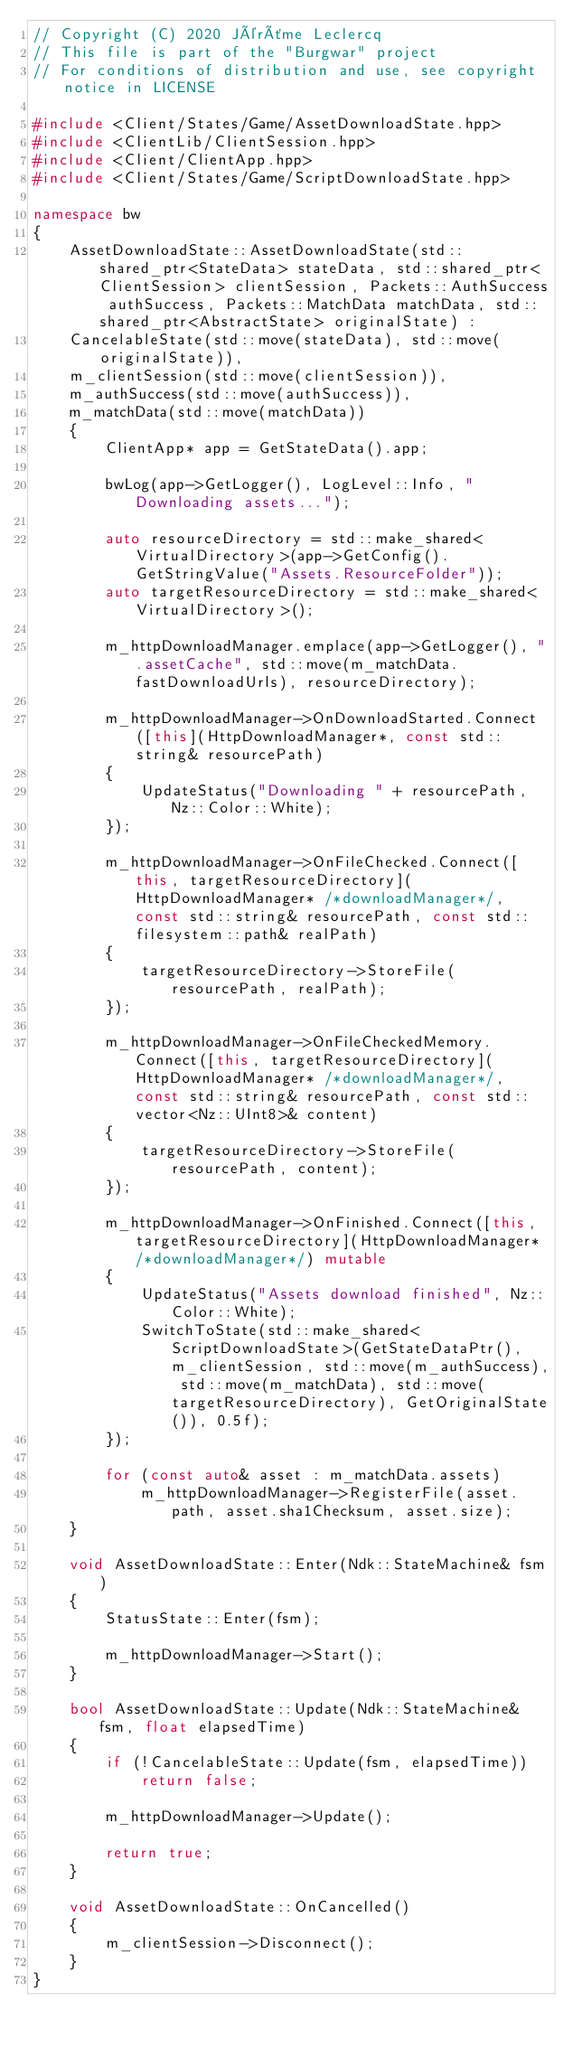<code> <loc_0><loc_0><loc_500><loc_500><_C++_>// Copyright (C) 2020 Jérôme Leclercq
// This file is part of the "Burgwar" project
// For conditions of distribution and use, see copyright notice in LICENSE

#include <Client/States/Game/AssetDownloadState.hpp>
#include <ClientLib/ClientSession.hpp>
#include <Client/ClientApp.hpp>
#include <Client/States/Game/ScriptDownloadState.hpp>

namespace bw
{
	AssetDownloadState::AssetDownloadState(std::shared_ptr<StateData> stateData, std::shared_ptr<ClientSession> clientSession, Packets::AuthSuccess authSuccess, Packets::MatchData matchData, std::shared_ptr<AbstractState> originalState) :
	CancelableState(std::move(stateData), std::move(originalState)),
	m_clientSession(std::move(clientSession)),
	m_authSuccess(std::move(authSuccess)),
	m_matchData(std::move(matchData))
	{
		ClientApp* app = GetStateData().app;

		bwLog(app->GetLogger(), LogLevel::Info, "Downloading assets...");

		auto resourceDirectory = std::make_shared<VirtualDirectory>(app->GetConfig().GetStringValue("Assets.ResourceFolder"));
		auto targetResourceDirectory = std::make_shared<VirtualDirectory>();

		m_httpDownloadManager.emplace(app->GetLogger(), ".assetCache", std::move(m_matchData.fastDownloadUrls), resourceDirectory);

		m_httpDownloadManager->OnDownloadStarted.Connect([this](HttpDownloadManager*, const std::string& resourcePath)
		{
			UpdateStatus("Downloading " + resourcePath, Nz::Color::White);
		});

		m_httpDownloadManager->OnFileChecked.Connect([this, targetResourceDirectory](HttpDownloadManager* /*downloadManager*/, const std::string& resourcePath, const std::filesystem::path& realPath)
		{
			targetResourceDirectory->StoreFile(resourcePath, realPath);
		});

		m_httpDownloadManager->OnFileCheckedMemory.Connect([this, targetResourceDirectory](HttpDownloadManager* /*downloadManager*/, const std::string& resourcePath, const std::vector<Nz::UInt8>& content)
		{
			targetResourceDirectory->StoreFile(resourcePath, content);
		});

		m_httpDownloadManager->OnFinished.Connect([this, targetResourceDirectory](HttpDownloadManager* /*downloadManager*/) mutable
		{
			UpdateStatus("Assets download finished", Nz::Color::White);
			SwitchToState(std::make_shared<ScriptDownloadState>(GetStateDataPtr(), m_clientSession, std::move(m_authSuccess), std::move(m_matchData), std::move(targetResourceDirectory), GetOriginalState()), 0.5f);
		});

		for (const auto& asset : m_matchData.assets)
			m_httpDownloadManager->RegisterFile(asset.path, asset.sha1Checksum, asset.size);
	}

	void AssetDownloadState::Enter(Ndk::StateMachine& fsm)
	{
		StatusState::Enter(fsm);

		m_httpDownloadManager->Start();
	}

	bool AssetDownloadState::Update(Ndk::StateMachine& fsm, float elapsedTime)
	{
		if (!CancelableState::Update(fsm, elapsedTime))
			return false;

		m_httpDownloadManager->Update();

		return true;
	}

	void AssetDownloadState::OnCancelled()
	{
		m_clientSession->Disconnect();
	}
}
</code> 